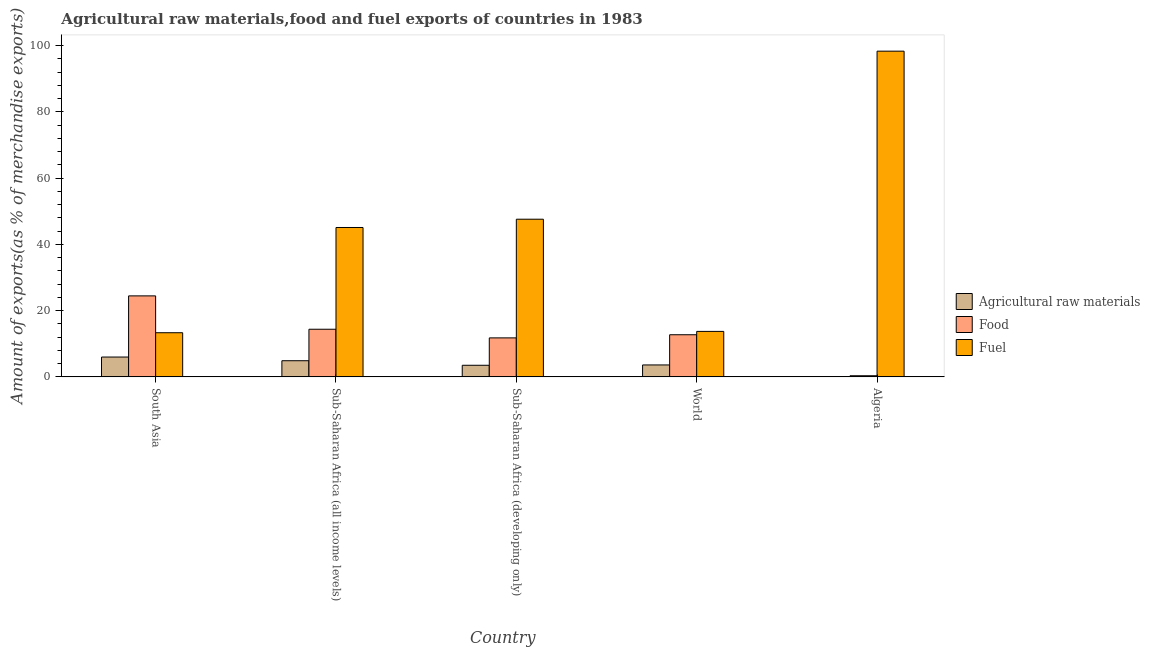How many bars are there on the 1st tick from the left?
Give a very brief answer. 3. What is the label of the 5th group of bars from the left?
Your answer should be very brief. Algeria. What is the percentage of raw materials exports in Algeria?
Provide a short and direct response. 0. Across all countries, what is the maximum percentage of raw materials exports?
Provide a succinct answer. 5.99. Across all countries, what is the minimum percentage of food exports?
Offer a very short reply. 0.34. In which country was the percentage of fuel exports maximum?
Make the answer very short. Algeria. In which country was the percentage of food exports minimum?
Your response must be concise. Algeria. What is the total percentage of raw materials exports in the graph?
Provide a short and direct response. 17.97. What is the difference between the percentage of fuel exports in Algeria and that in Sub-Saharan Africa (developing only)?
Ensure brevity in your answer.  50.73. What is the difference between the percentage of food exports in South Asia and the percentage of raw materials exports in World?
Your answer should be compact. 20.85. What is the average percentage of fuel exports per country?
Provide a short and direct response. 43.61. What is the difference between the percentage of raw materials exports and percentage of food exports in Sub-Saharan Africa (all income levels)?
Your answer should be compact. -9.5. In how many countries, is the percentage of food exports greater than 40 %?
Your answer should be compact. 0. What is the ratio of the percentage of food exports in Sub-Saharan Africa (developing only) to that in World?
Your answer should be very brief. 0.93. Is the percentage of food exports in South Asia less than that in Sub-Saharan Africa (developing only)?
Your response must be concise. No. What is the difference between the highest and the second highest percentage of fuel exports?
Provide a short and direct response. 50.73. What is the difference between the highest and the lowest percentage of food exports?
Make the answer very short. 24.11. Is the sum of the percentage of food exports in Sub-Saharan Africa (all income levels) and World greater than the maximum percentage of fuel exports across all countries?
Provide a succinct answer. No. What does the 3rd bar from the left in Sub-Saharan Africa (all income levels) represents?
Provide a succinct answer. Fuel. What does the 1st bar from the right in South Asia represents?
Provide a succinct answer. Fuel. How many countries are there in the graph?
Your answer should be compact. 5. What is the difference between two consecutive major ticks on the Y-axis?
Your answer should be very brief. 20. Are the values on the major ticks of Y-axis written in scientific E-notation?
Provide a short and direct response. No. Does the graph contain grids?
Offer a terse response. No. Where does the legend appear in the graph?
Provide a succinct answer. Center right. What is the title of the graph?
Your answer should be very brief. Agricultural raw materials,food and fuel exports of countries in 1983. Does "Argument" appear as one of the legend labels in the graph?
Your response must be concise. No. What is the label or title of the Y-axis?
Your response must be concise. Amount of exports(as % of merchandise exports). What is the Amount of exports(as % of merchandise exports) in Agricultural raw materials in South Asia?
Provide a short and direct response. 5.99. What is the Amount of exports(as % of merchandise exports) in Food in South Asia?
Provide a succinct answer. 24.45. What is the Amount of exports(as % of merchandise exports) of Fuel in South Asia?
Give a very brief answer. 13.33. What is the Amount of exports(as % of merchandise exports) in Agricultural raw materials in Sub-Saharan Africa (all income levels)?
Provide a short and direct response. 4.88. What is the Amount of exports(as % of merchandise exports) of Food in Sub-Saharan Africa (all income levels)?
Offer a very short reply. 14.38. What is the Amount of exports(as % of merchandise exports) of Fuel in Sub-Saharan Africa (all income levels)?
Give a very brief answer. 45.09. What is the Amount of exports(as % of merchandise exports) in Agricultural raw materials in Sub-Saharan Africa (developing only)?
Keep it short and to the point. 3.5. What is the Amount of exports(as % of merchandise exports) in Food in Sub-Saharan Africa (developing only)?
Give a very brief answer. 11.77. What is the Amount of exports(as % of merchandise exports) in Fuel in Sub-Saharan Africa (developing only)?
Offer a terse response. 47.59. What is the Amount of exports(as % of merchandise exports) in Agricultural raw materials in World?
Make the answer very short. 3.6. What is the Amount of exports(as % of merchandise exports) of Food in World?
Make the answer very short. 12.72. What is the Amount of exports(as % of merchandise exports) in Fuel in World?
Provide a succinct answer. 13.73. What is the Amount of exports(as % of merchandise exports) of Agricultural raw materials in Algeria?
Ensure brevity in your answer.  0. What is the Amount of exports(as % of merchandise exports) in Food in Algeria?
Ensure brevity in your answer.  0.34. What is the Amount of exports(as % of merchandise exports) of Fuel in Algeria?
Offer a very short reply. 98.32. Across all countries, what is the maximum Amount of exports(as % of merchandise exports) in Agricultural raw materials?
Offer a terse response. 5.99. Across all countries, what is the maximum Amount of exports(as % of merchandise exports) of Food?
Keep it short and to the point. 24.45. Across all countries, what is the maximum Amount of exports(as % of merchandise exports) of Fuel?
Offer a very short reply. 98.32. Across all countries, what is the minimum Amount of exports(as % of merchandise exports) in Agricultural raw materials?
Offer a terse response. 0. Across all countries, what is the minimum Amount of exports(as % of merchandise exports) in Food?
Keep it short and to the point. 0.34. Across all countries, what is the minimum Amount of exports(as % of merchandise exports) in Fuel?
Your answer should be compact. 13.33. What is the total Amount of exports(as % of merchandise exports) in Agricultural raw materials in the graph?
Provide a succinct answer. 17.97. What is the total Amount of exports(as % of merchandise exports) in Food in the graph?
Your answer should be very brief. 63.65. What is the total Amount of exports(as % of merchandise exports) of Fuel in the graph?
Your answer should be very brief. 218.07. What is the difference between the Amount of exports(as % of merchandise exports) of Agricultural raw materials in South Asia and that in Sub-Saharan Africa (all income levels)?
Provide a succinct answer. 1.11. What is the difference between the Amount of exports(as % of merchandise exports) of Food in South Asia and that in Sub-Saharan Africa (all income levels)?
Your answer should be very brief. 10.07. What is the difference between the Amount of exports(as % of merchandise exports) in Fuel in South Asia and that in Sub-Saharan Africa (all income levels)?
Provide a succinct answer. -31.77. What is the difference between the Amount of exports(as % of merchandise exports) of Agricultural raw materials in South Asia and that in Sub-Saharan Africa (developing only)?
Give a very brief answer. 2.49. What is the difference between the Amount of exports(as % of merchandise exports) in Food in South Asia and that in Sub-Saharan Africa (developing only)?
Your response must be concise. 12.68. What is the difference between the Amount of exports(as % of merchandise exports) of Fuel in South Asia and that in Sub-Saharan Africa (developing only)?
Provide a short and direct response. -34.27. What is the difference between the Amount of exports(as % of merchandise exports) in Agricultural raw materials in South Asia and that in World?
Make the answer very short. 2.39. What is the difference between the Amount of exports(as % of merchandise exports) in Food in South Asia and that in World?
Your answer should be very brief. 11.73. What is the difference between the Amount of exports(as % of merchandise exports) of Fuel in South Asia and that in World?
Provide a short and direct response. -0.4. What is the difference between the Amount of exports(as % of merchandise exports) of Agricultural raw materials in South Asia and that in Algeria?
Ensure brevity in your answer.  5.99. What is the difference between the Amount of exports(as % of merchandise exports) in Food in South Asia and that in Algeria?
Your answer should be compact. 24.11. What is the difference between the Amount of exports(as % of merchandise exports) of Fuel in South Asia and that in Algeria?
Your response must be concise. -85. What is the difference between the Amount of exports(as % of merchandise exports) of Agricultural raw materials in Sub-Saharan Africa (all income levels) and that in Sub-Saharan Africa (developing only)?
Make the answer very short. 1.37. What is the difference between the Amount of exports(as % of merchandise exports) of Food in Sub-Saharan Africa (all income levels) and that in Sub-Saharan Africa (developing only)?
Make the answer very short. 2.61. What is the difference between the Amount of exports(as % of merchandise exports) of Fuel in Sub-Saharan Africa (all income levels) and that in Sub-Saharan Africa (developing only)?
Give a very brief answer. -2.5. What is the difference between the Amount of exports(as % of merchandise exports) in Agricultural raw materials in Sub-Saharan Africa (all income levels) and that in World?
Ensure brevity in your answer.  1.27. What is the difference between the Amount of exports(as % of merchandise exports) in Food in Sub-Saharan Africa (all income levels) and that in World?
Offer a terse response. 1.66. What is the difference between the Amount of exports(as % of merchandise exports) of Fuel in Sub-Saharan Africa (all income levels) and that in World?
Make the answer very short. 31.36. What is the difference between the Amount of exports(as % of merchandise exports) in Agricultural raw materials in Sub-Saharan Africa (all income levels) and that in Algeria?
Offer a very short reply. 4.87. What is the difference between the Amount of exports(as % of merchandise exports) of Food in Sub-Saharan Africa (all income levels) and that in Algeria?
Make the answer very short. 14.04. What is the difference between the Amount of exports(as % of merchandise exports) of Fuel in Sub-Saharan Africa (all income levels) and that in Algeria?
Give a very brief answer. -53.23. What is the difference between the Amount of exports(as % of merchandise exports) of Agricultural raw materials in Sub-Saharan Africa (developing only) and that in World?
Offer a terse response. -0.1. What is the difference between the Amount of exports(as % of merchandise exports) of Food in Sub-Saharan Africa (developing only) and that in World?
Make the answer very short. -0.94. What is the difference between the Amount of exports(as % of merchandise exports) of Fuel in Sub-Saharan Africa (developing only) and that in World?
Ensure brevity in your answer.  33.87. What is the difference between the Amount of exports(as % of merchandise exports) of Agricultural raw materials in Sub-Saharan Africa (developing only) and that in Algeria?
Your answer should be very brief. 3.5. What is the difference between the Amount of exports(as % of merchandise exports) of Food in Sub-Saharan Africa (developing only) and that in Algeria?
Keep it short and to the point. 11.43. What is the difference between the Amount of exports(as % of merchandise exports) in Fuel in Sub-Saharan Africa (developing only) and that in Algeria?
Keep it short and to the point. -50.73. What is the difference between the Amount of exports(as % of merchandise exports) of Agricultural raw materials in World and that in Algeria?
Offer a very short reply. 3.6. What is the difference between the Amount of exports(as % of merchandise exports) of Food in World and that in Algeria?
Your response must be concise. 12.38. What is the difference between the Amount of exports(as % of merchandise exports) of Fuel in World and that in Algeria?
Keep it short and to the point. -84.6. What is the difference between the Amount of exports(as % of merchandise exports) in Agricultural raw materials in South Asia and the Amount of exports(as % of merchandise exports) in Food in Sub-Saharan Africa (all income levels)?
Ensure brevity in your answer.  -8.39. What is the difference between the Amount of exports(as % of merchandise exports) in Agricultural raw materials in South Asia and the Amount of exports(as % of merchandise exports) in Fuel in Sub-Saharan Africa (all income levels)?
Ensure brevity in your answer.  -39.1. What is the difference between the Amount of exports(as % of merchandise exports) in Food in South Asia and the Amount of exports(as % of merchandise exports) in Fuel in Sub-Saharan Africa (all income levels)?
Your response must be concise. -20.64. What is the difference between the Amount of exports(as % of merchandise exports) of Agricultural raw materials in South Asia and the Amount of exports(as % of merchandise exports) of Food in Sub-Saharan Africa (developing only)?
Make the answer very short. -5.78. What is the difference between the Amount of exports(as % of merchandise exports) in Agricultural raw materials in South Asia and the Amount of exports(as % of merchandise exports) in Fuel in Sub-Saharan Africa (developing only)?
Make the answer very short. -41.61. What is the difference between the Amount of exports(as % of merchandise exports) in Food in South Asia and the Amount of exports(as % of merchandise exports) in Fuel in Sub-Saharan Africa (developing only)?
Offer a terse response. -23.15. What is the difference between the Amount of exports(as % of merchandise exports) in Agricultural raw materials in South Asia and the Amount of exports(as % of merchandise exports) in Food in World?
Your answer should be very brief. -6.73. What is the difference between the Amount of exports(as % of merchandise exports) in Agricultural raw materials in South Asia and the Amount of exports(as % of merchandise exports) in Fuel in World?
Make the answer very short. -7.74. What is the difference between the Amount of exports(as % of merchandise exports) of Food in South Asia and the Amount of exports(as % of merchandise exports) of Fuel in World?
Offer a terse response. 10.72. What is the difference between the Amount of exports(as % of merchandise exports) of Agricultural raw materials in South Asia and the Amount of exports(as % of merchandise exports) of Food in Algeria?
Ensure brevity in your answer.  5.65. What is the difference between the Amount of exports(as % of merchandise exports) in Agricultural raw materials in South Asia and the Amount of exports(as % of merchandise exports) in Fuel in Algeria?
Ensure brevity in your answer.  -92.34. What is the difference between the Amount of exports(as % of merchandise exports) of Food in South Asia and the Amount of exports(as % of merchandise exports) of Fuel in Algeria?
Your response must be concise. -73.87. What is the difference between the Amount of exports(as % of merchandise exports) in Agricultural raw materials in Sub-Saharan Africa (all income levels) and the Amount of exports(as % of merchandise exports) in Food in Sub-Saharan Africa (developing only)?
Your answer should be very brief. -6.89. What is the difference between the Amount of exports(as % of merchandise exports) of Agricultural raw materials in Sub-Saharan Africa (all income levels) and the Amount of exports(as % of merchandise exports) of Fuel in Sub-Saharan Africa (developing only)?
Provide a short and direct response. -42.72. What is the difference between the Amount of exports(as % of merchandise exports) of Food in Sub-Saharan Africa (all income levels) and the Amount of exports(as % of merchandise exports) of Fuel in Sub-Saharan Africa (developing only)?
Your response must be concise. -33.22. What is the difference between the Amount of exports(as % of merchandise exports) in Agricultural raw materials in Sub-Saharan Africa (all income levels) and the Amount of exports(as % of merchandise exports) in Food in World?
Keep it short and to the point. -7.84. What is the difference between the Amount of exports(as % of merchandise exports) in Agricultural raw materials in Sub-Saharan Africa (all income levels) and the Amount of exports(as % of merchandise exports) in Fuel in World?
Give a very brief answer. -8.85. What is the difference between the Amount of exports(as % of merchandise exports) of Food in Sub-Saharan Africa (all income levels) and the Amount of exports(as % of merchandise exports) of Fuel in World?
Your answer should be compact. 0.65. What is the difference between the Amount of exports(as % of merchandise exports) in Agricultural raw materials in Sub-Saharan Africa (all income levels) and the Amount of exports(as % of merchandise exports) in Food in Algeria?
Ensure brevity in your answer.  4.54. What is the difference between the Amount of exports(as % of merchandise exports) in Agricultural raw materials in Sub-Saharan Africa (all income levels) and the Amount of exports(as % of merchandise exports) in Fuel in Algeria?
Your response must be concise. -93.45. What is the difference between the Amount of exports(as % of merchandise exports) in Food in Sub-Saharan Africa (all income levels) and the Amount of exports(as % of merchandise exports) in Fuel in Algeria?
Offer a terse response. -83.95. What is the difference between the Amount of exports(as % of merchandise exports) in Agricultural raw materials in Sub-Saharan Africa (developing only) and the Amount of exports(as % of merchandise exports) in Food in World?
Offer a terse response. -9.21. What is the difference between the Amount of exports(as % of merchandise exports) in Agricultural raw materials in Sub-Saharan Africa (developing only) and the Amount of exports(as % of merchandise exports) in Fuel in World?
Offer a very short reply. -10.23. What is the difference between the Amount of exports(as % of merchandise exports) of Food in Sub-Saharan Africa (developing only) and the Amount of exports(as % of merchandise exports) of Fuel in World?
Provide a short and direct response. -1.96. What is the difference between the Amount of exports(as % of merchandise exports) of Agricultural raw materials in Sub-Saharan Africa (developing only) and the Amount of exports(as % of merchandise exports) of Food in Algeria?
Make the answer very short. 3.16. What is the difference between the Amount of exports(as % of merchandise exports) of Agricultural raw materials in Sub-Saharan Africa (developing only) and the Amount of exports(as % of merchandise exports) of Fuel in Algeria?
Give a very brief answer. -94.82. What is the difference between the Amount of exports(as % of merchandise exports) of Food in Sub-Saharan Africa (developing only) and the Amount of exports(as % of merchandise exports) of Fuel in Algeria?
Give a very brief answer. -86.55. What is the difference between the Amount of exports(as % of merchandise exports) in Agricultural raw materials in World and the Amount of exports(as % of merchandise exports) in Food in Algeria?
Your answer should be very brief. 3.26. What is the difference between the Amount of exports(as % of merchandise exports) of Agricultural raw materials in World and the Amount of exports(as % of merchandise exports) of Fuel in Algeria?
Provide a succinct answer. -94.72. What is the difference between the Amount of exports(as % of merchandise exports) of Food in World and the Amount of exports(as % of merchandise exports) of Fuel in Algeria?
Your answer should be compact. -85.61. What is the average Amount of exports(as % of merchandise exports) in Agricultural raw materials per country?
Your response must be concise. 3.59. What is the average Amount of exports(as % of merchandise exports) in Food per country?
Your response must be concise. 12.73. What is the average Amount of exports(as % of merchandise exports) in Fuel per country?
Provide a short and direct response. 43.61. What is the difference between the Amount of exports(as % of merchandise exports) of Agricultural raw materials and Amount of exports(as % of merchandise exports) of Food in South Asia?
Make the answer very short. -18.46. What is the difference between the Amount of exports(as % of merchandise exports) in Agricultural raw materials and Amount of exports(as % of merchandise exports) in Fuel in South Asia?
Provide a succinct answer. -7.34. What is the difference between the Amount of exports(as % of merchandise exports) in Food and Amount of exports(as % of merchandise exports) in Fuel in South Asia?
Keep it short and to the point. 11.12. What is the difference between the Amount of exports(as % of merchandise exports) of Agricultural raw materials and Amount of exports(as % of merchandise exports) of Food in Sub-Saharan Africa (all income levels)?
Provide a succinct answer. -9.5. What is the difference between the Amount of exports(as % of merchandise exports) of Agricultural raw materials and Amount of exports(as % of merchandise exports) of Fuel in Sub-Saharan Africa (all income levels)?
Your answer should be compact. -40.22. What is the difference between the Amount of exports(as % of merchandise exports) in Food and Amount of exports(as % of merchandise exports) in Fuel in Sub-Saharan Africa (all income levels)?
Your response must be concise. -30.72. What is the difference between the Amount of exports(as % of merchandise exports) of Agricultural raw materials and Amount of exports(as % of merchandise exports) of Food in Sub-Saharan Africa (developing only)?
Your response must be concise. -8.27. What is the difference between the Amount of exports(as % of merchandise exports) of Agricultural raw materials and Amount of exports(as % of merchandise exports) of Fuel in Sub-Saharan Africa (developing only)?
Your response must be concise. -44.09. What is the difference between the Amount of exports(as % of merchandise exports) of Food and Amount of exports(as % of merchandise exports) of Fuel in Sub-Saharan Africa (developing only)?
Ensure brevity in your answer.  -35.82. What is the difference between the Amount of exports(as % of merchandise exports) of Agricultural raw materials and Amount of exports(as % of merchandise exports) of Food in World?
Offer a very short reply. -9.11. What is the difference between the Amount of exports(as % of merchandise exports) of Agricultural raw materials and Amount of exports(as % of merchandise exports) of Fuel in World?
Keep it short and to the point. -10.13. What is the difference between the Amount of exports(as % of merchandise exports) in Food and Amount of exports(as % of merchandise exports) in Fuel in World?
Keep it short and to the point. -1.01. What is the difference between the Amount of exports(as % of merchandise exports) of Agricultural raw materials and Amount of exports(as % of merchandise exports) of Food in Algeria?
Keep it short and to the point. -0.34. What is the difference between the Amount of exports(as % of merchandise exports) of Agricultural raw materials and Amount of exports(as % of merchandise exports) of Fuel in Algeria?
Your response must be concise. -98.32. What is the difference between the Amount of exports(as % of merchandise exports) of Food and Amount of exports(as % of merchandise exports) of Fuel in Algeria?
Ensure brevity in your answer.  -97.98. What is the ratio of the Amount of exports(as % of merchandise exports) of Agricultural raw materials in South Asia to that in Sub-Saharan Africa (all income levels)?
Offer a terse response. 1.23. What is the ratio of the Amount of exports(as % of merchandise exports) of Food in South Asia to that in Sub-Saharan Africa (all income levels)?
Offer a terse response. 1.7. What is the ratio of the Amount of exports(as % of merchandise exports) of Fuel in South Asia to that in Sub-Saharan Africa (all income levels)?
Ensure brevity in your answer.  0.3. What is the ratio of the Amount of exports(as % of merchandise exports) of Agricultural raw materials in South Asia to that in Sub-Saharan Africa (developing only)?
Provide a short and direct response. 1.71. What is the ratio of the Amount of exports(as % of merchandise exports) of Food in South Asia to that in Sub-Saharan Africa (developing only)?
Provide a short and direct response. 2.08. What is the ratio of the Amount of exports(as % of merchandise exports) of Fuel in South Asia to that in Sub-Saharan Africa (developing only)?
Offer a terse response. 0.28. What is the ratio of the Amount of exports(as % of merchandise exports) in Agricultural raw materials in South Asia to that in World?
Your answer should be very brief. 1.66. What is the ratio of the Amount of exports(as % of merchandise exports) in Food in South Asia to that in World?
Make the answer very short. 1.92. What is the ratio of the Amount of exports(as % of merchandise exports) in Fuel in South Asia to that in World?
Offer a very short reply. 0.97. What is the ratio of the Amount of exports(as % of merchandise exports) in Agricultural raw materials in South Asia to that in Algeria?
Make the answer very short. 3015.19. What is the ratio of the Amount of exports(as % of merchandise exports) of Food in South Asia to that in Algeria?
Offer a terse response. 72.17. What is the ratio of the Amount of exports(as % of merchandise exports) in Fuel in South Asia to that in Algeria?
Provide a short and direct response. 0.14. What is the ratio of the Amount of exports(as % of merchandise exports) in Agricultural raw materials in Sub-Saharan Africa (all income levels) to that in Sub-Saharan Africa (developing only)?
Your answer should be compact. 1.39. What is the ratio of the Amount of exports(as % of merchandise exports) of Food in Sub-Saharan Africa (all income levels) to that in Sub-Saharan Africa (developing only)?
Your response must be concise. 1.22. What is the ratio of the Amount of exports(as % of merchandise exports) of Agricultural raw materials in Sub-Saharan Africa (all income levels) to that in World?
Offer a terse response. 1.35. What is the ratio of the Amount of exports(as % of merchandise exports) of Food in Sub-Saharan Africa (all income levels) to that in World?
Offer a terse response. 1.13. What is the ratio of the Amount of exports(as % of merchandise exports) of Fuel in Sub-Saharan Africa (all income levels) to that in World?
Your answer should be very brief. 3.28. What is the ratio of the Amount of exports(as % of merchandise exports) in Agricultural raw materials in Sub-Saharan Africa (all income levels) to that in Algeria?
Provide a succinct answer. 2454.99. What is the ratio of the Amount of exports(as % of merchandise exports) of Food in Sub-Saharan Africa (all income levels) to that in Algeria?
Your answer should be very brief. 42.44. What is the ratio of the Amount of exports(as % of merchandise exports) in Fuel in Sub-Saharan Africa (all income levels) to that in Algeria?
Ensure brevity in your answer.  0.46. What is the ratio of the Amount of exports(as % of merchandise exports) in Agricultural raw materials in Sub-Saharan Africa (developing only) to that in World?
Provide a short and direct response. 0.97. What is the ratio of the Amount of exports(as % of merchandise exports) of Food in Sub-Saharan Africa (developing only) to that in World?
Offer a very short reply. 0.93. What is the ratio of the Amount of exports(as % of merchandise exports) in Fuel in Sub-Saharan Africa (developing only) to that in World?
Your answer should be compact. 3.47. What is the ratio of the Amount of exports(as % of merchandise exports) of Agricultural raw materials in Sub-Saharan Africa (developing only) to that in Algeria?
Offer a terse response. 1763.06. What is the ratio of the Amount of exports(as % of merchandise exports) of Food in Sub-Saharan Africa (developing only) to that in Algeria?
Offer a very short reply. 34.74. What is the ratio of the Amount of exports(as % of merchandise exports) of Fuel in Sub-Saharan Africa (developing only) to that in Algeria?
Offer a terse response. 0.48. What is the ratio of the Amount of exports(as % of merchandise exports) in Agricultural raw materials in World to that in Algeria?
Offer a very short reply. 1813.31. What is the ratio of the Amount of exports(as % of merchandise exports) in Food in World to that in Algeria?
Provide a short and direct response. 37.53. What is the ratio of the Amount of exports(as % of merchandise exports) of Fuel in World to that in Algeria?
Give a very brief answer. 0.14. What is the difference between the highest and the second highest Amount of exports(as % of merchandise exports) of Agricultural raw materials?
Make the answer very short. 1.11. What is the difference between the highest and the second highest Amount of exports(as % of merchandise exports) of Food?
Ensure brevity in your answer.  10.07. What is the difference between the highest and the second highest Amount of exports(as % of merchandise exports) of Fuel?
Make the answer very short. 50.73. What is the difference between the highest and the lowest Amount of exports(as % of merchandise exports) in Agricultural raw materials?
Your answer should be compact. 5.99. What is the difference between the highest and the lowest Amount of exports(as % of merchandise exports) in Food?
Provide a short and direct response. 24.11. What is the difference between the highest and the lowest Amount of exports(as % of merchandise exports) of Fuel?
Your answer should be very brief. 85. 